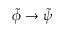Convert formula to latex. <formula><loc_0><loc_0><loc_500><loc_500>\tilde { \phi } \to \tilde { \psi }</formula> 